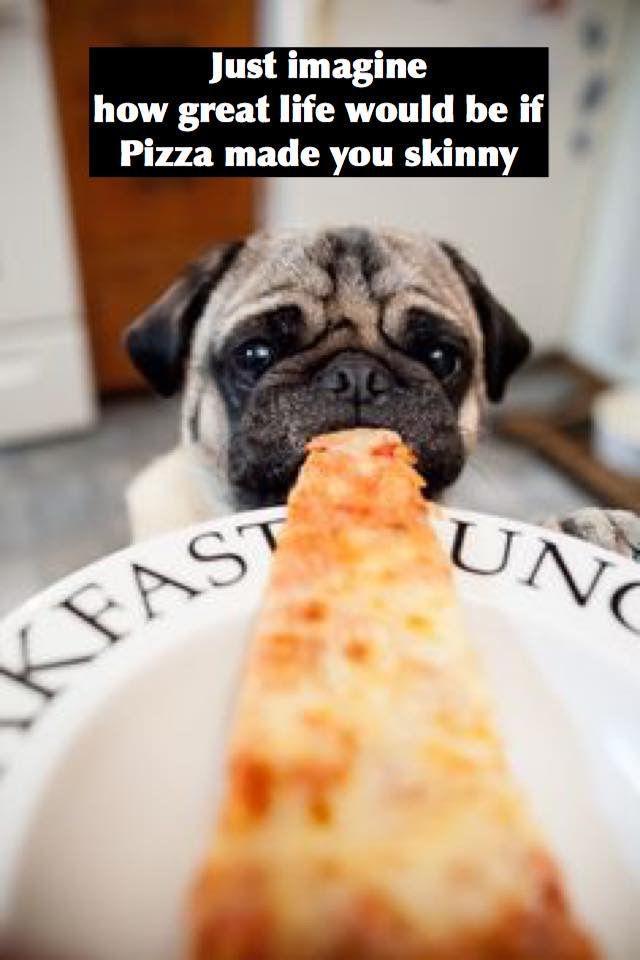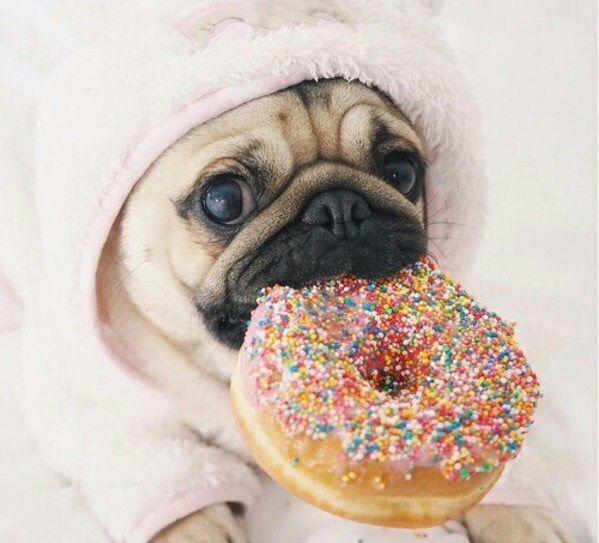The first image is the image on the left, the second image is the image on the right. For the images shown, is this caption "An image shows a pug with a propped elbow reclining in an open white box in front of stacks of white boxes." true? Answer yes or no. No. The first image is the image on the left, the second image is the image on the right. For the images displayed, is the sentence "There is a pug eating a slice of pizza, and another pug not eating a slice of pizza." factually correct? Answer yes or no. Yes. 